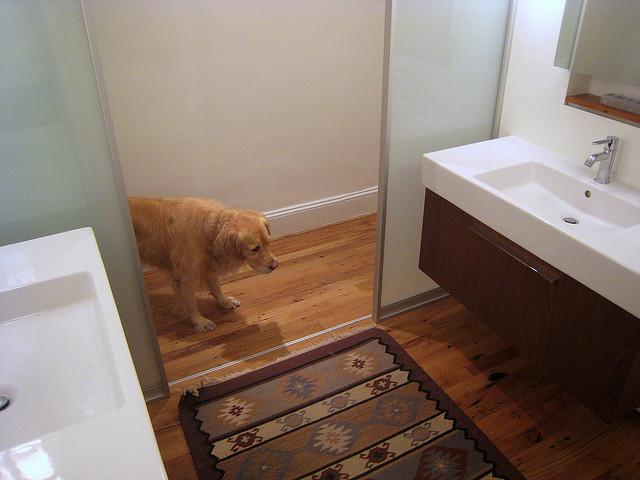What color is the dog standing inside of the doorway to the bathroom? Please explain your reasoning. golden. The dog is a golden retriever. 